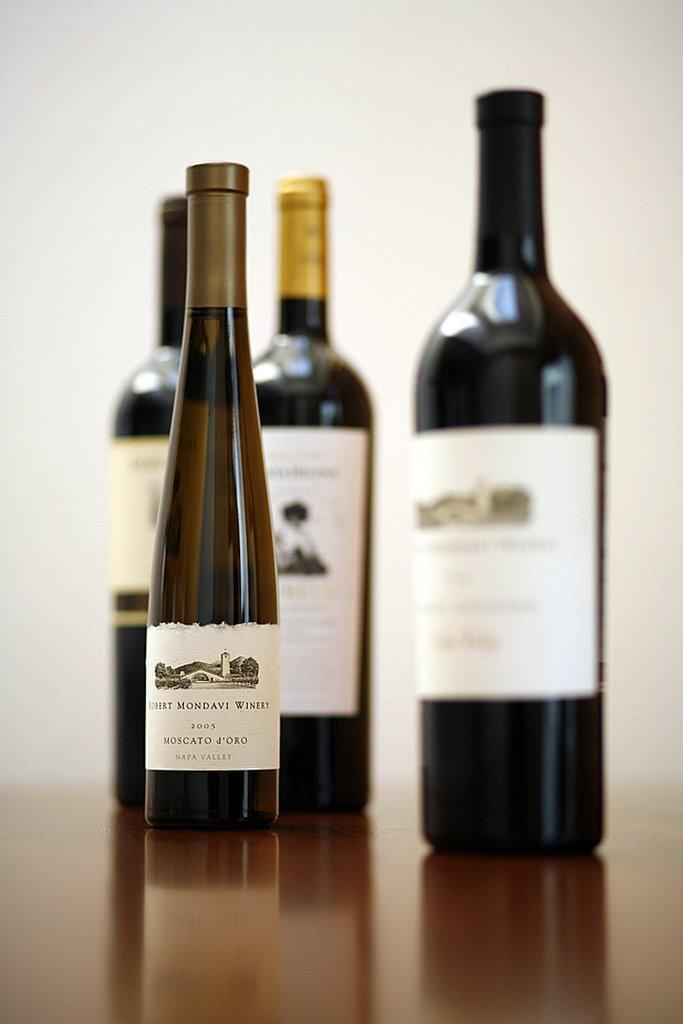<image>
Write a terse but informative summary of the picture. 4 bottles of wine sitting on a wooden table with one being Moscato J'Oro. 